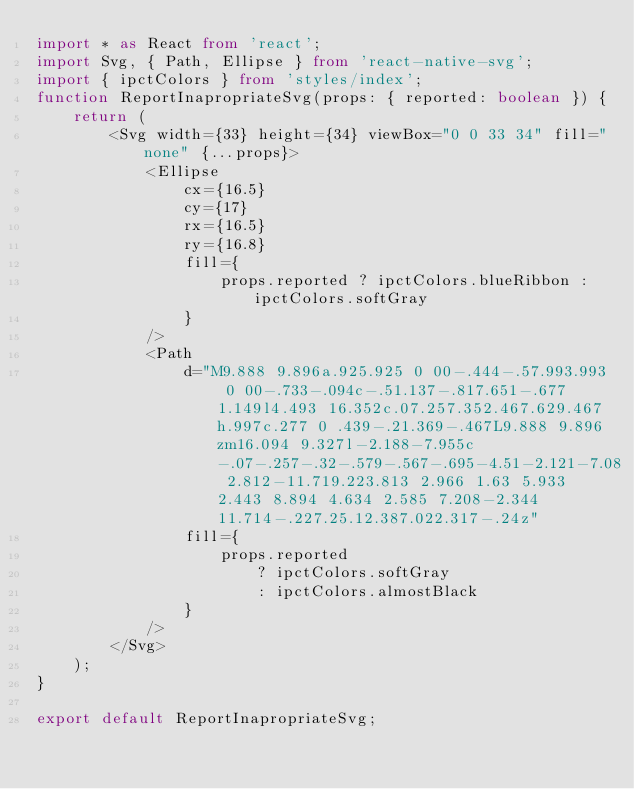<code> <loc_0><loc_0><loc_500><loc_500><_TypeScript_>import * as React from 'react';
import Svg, { Path, Ellipse } from 'react-native-svg';
import { ipctColors } from 'styles/index';
function ReportInapropriateSvg(props: { reported: boolean }) {
    return (
        <Svg width={33} height={34} viewBox="0 0 33 34" fill="none" {...props}>
            <Ellipse
                cx={16.5}
                cy={17}
                rx={16.5}
                ry={16.8}
                fill={
                    props.reported ? ipctColors.blueRibbon : ipctColors.softGray
                }
            />
            <Path
                d="M9.888 9.896a.925.925 0 00-.444-.57.993.993 0 00-.733-.094c-.51.137-.817.651-.677 1.149l4.493 16.352c.07.257.352.467.629.467h.997c.277 0 .439-.21.369-.467L9.888 9.896zm16.094 9.327l-2.188-7.955c-.07-.257-.32-.579-.567-.695-4.51-2.121-7.08 2.812-11.719.223.813 2.966 1.63 5.933 2.443 8.894 4.634 2.585 7.208-2.344 11.714-.227.25.12.387.022.317-.24z"
                fill={
                    props.reported
                        ? ipctColors.softGray
                        : ipctColors.almostBlack
                }
            />
        </Svg>
    );
}

export default ReportInapropriateSvg;
</code> 